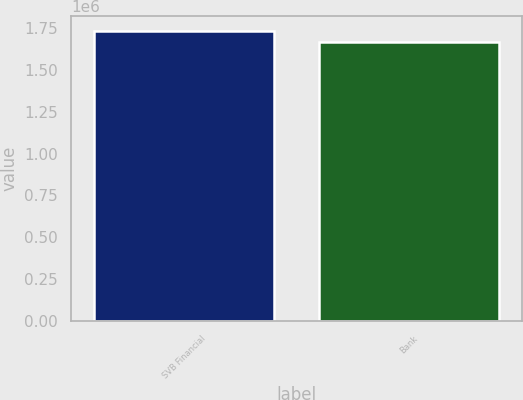Convert chart to OTSL. <chart><loc_0><loc_0><loc_500><loc_500><bar_chart><fcel>SVB Financial<fcel>Bank<nl><fcel>1.73375e+06<fcel>1.66968e+06<nl></chart> 